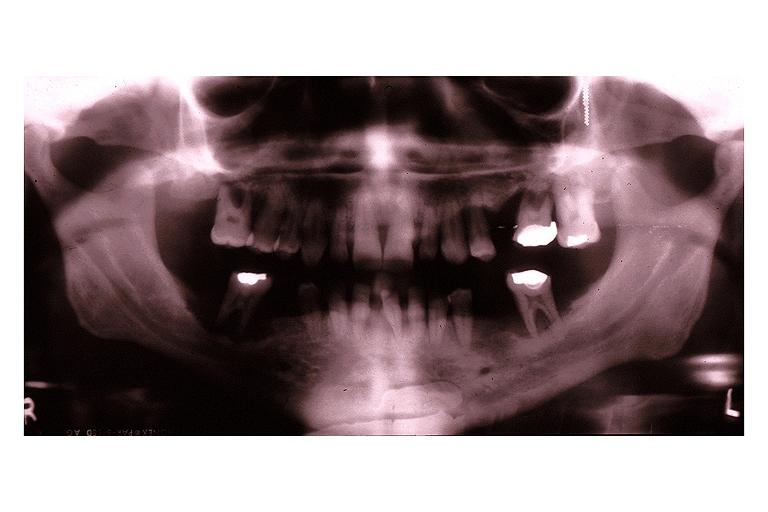what is present?
Answer the question using a single word or phrase. Oral 